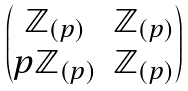Convert formula to latex. <formula><loc_0><loc_0><loc_500><loc_500>\begin{pmatrix} { \mathbb { Z } _ { ( p ) } } & { \mathbb { Z } _ { ( p ) } } \\ { p \mathbb { Z } _ { ( p ) } } & { \mathbb { Z } _ { ( p ) } } \end{pmatrix}</formula> 